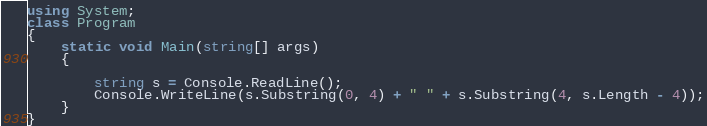Convert code to text. <code><loc_0><loc_0><loc_500><loc_500><_C#_>using System;
class Program
{
	static void Main(string[] args)
	{

		string s = Console.ReadLine();
        Console.WriteLine(s.Substring(0, 4) + " " + s.Substring(4, s.Length - 4));
	}
}
</code> 